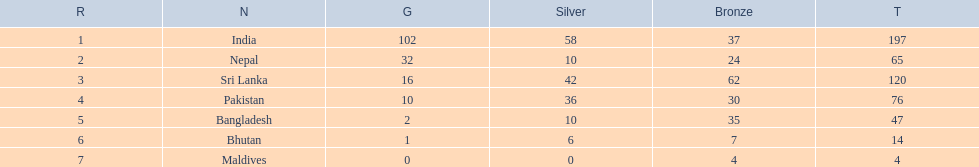Name a country listed in the table, other than india? Nepal. 